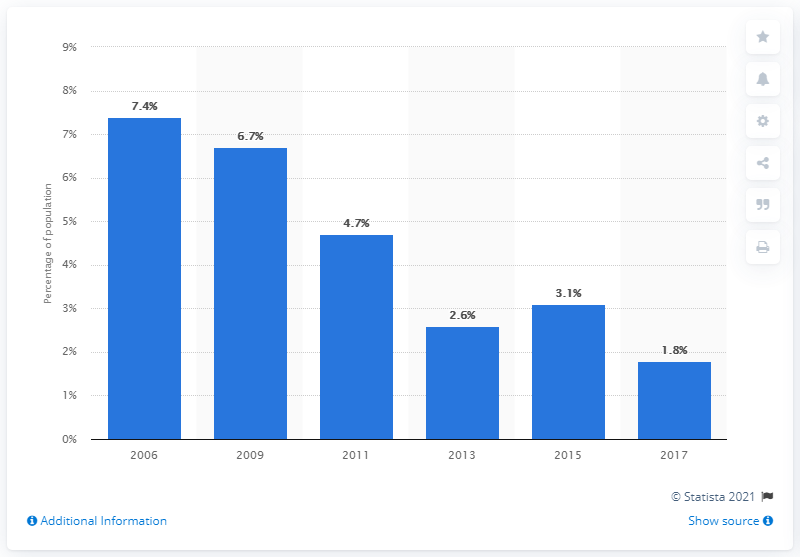Draw attention to some important aspects in this diagram. In 2017, an estimated 1.8% of Chile's population lived on less than $3.20 per day, according to data. 